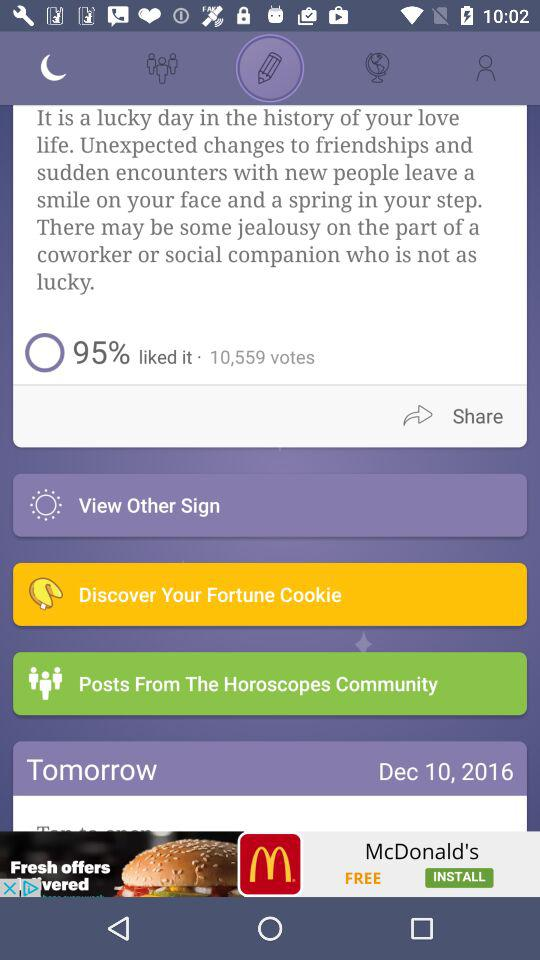What percentage of people liked it? It was liked by 95 percent of people. 